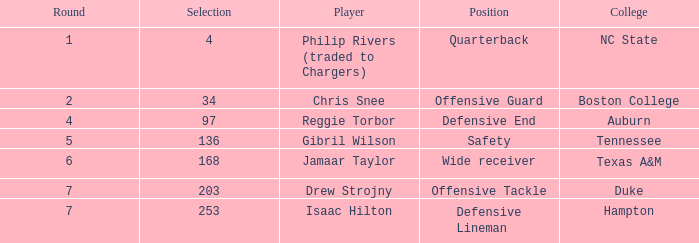Can you parse all the data within this table? {'header': ['Round', 'Selection', 'Player', 'Position', 'College'], 'rows': [['1', '4', 'Philip Rivers (traded to Chargers)', 'Quarterback', 'NC State'], ['2', '34', 'Chris Snee', 'Offensive Guard', 'Boston College'], ['4', '97', 'Reggie Torbor', 'Defensive End', 'Auburn'], ['5', '136', 'Gibril Wilson', 'Safety', 'Tennessee'], ['6', '168', 'Jamaar Taylor', 'Wide receiver', 'Texas A&M'], ['7', '203', 'Drew Strojny', 'Offensive Tackle', 'Duke'], ['7', '253', 'Isaac Hilton', 'Defensive Lineman', 'Hampton']]} Which Selection has a College of texas a&m? 168.0. 